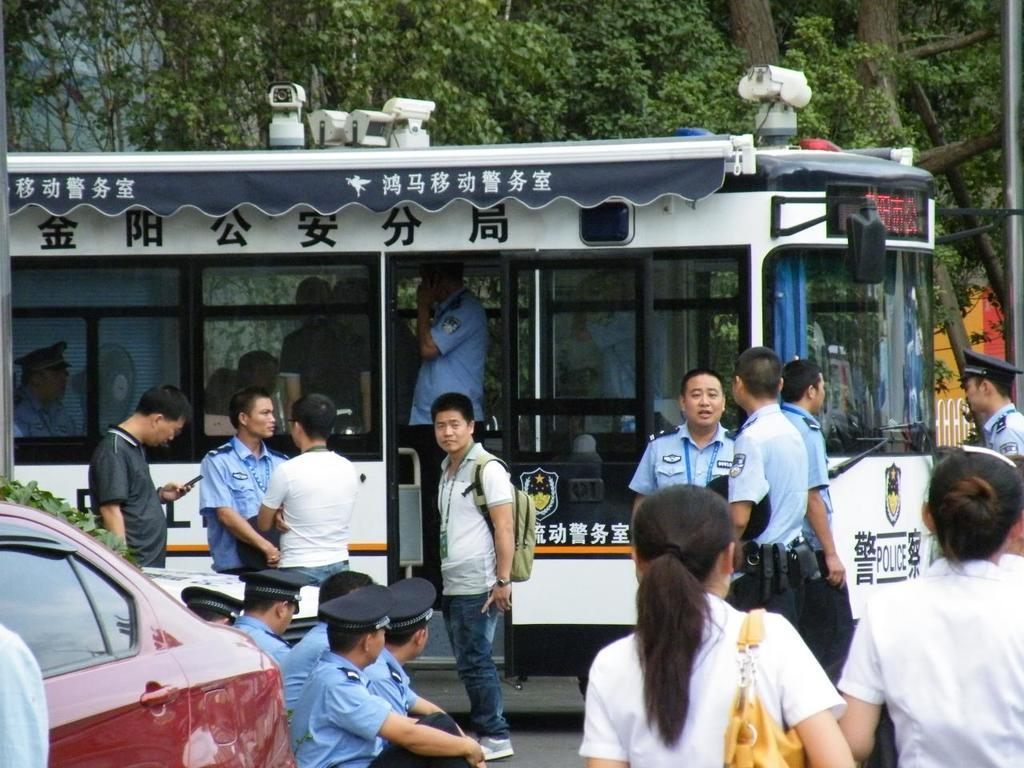<image>
Give a short and clear explanation of the subsequent image. a bunch of people and police officers  in front of  white bus with Chinese letters all over. 